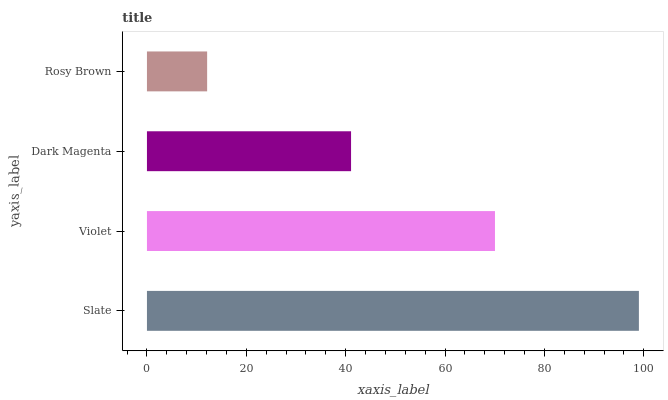Is Rosy Brown the minimum?
Answer yes or no. Yes. Is Slate the maximum?
Answer yes or no. Yes. Is Violet the minimum?
Answer yes or no. No. Is Violet the maximum?
Answer yes or no. No. Is Slate greater than Violet?
Answer yes or no. Yes. Is Violet less than Slate?
Answer yes or no. Yes. Is Violet greater than Slate?
Answer yes or no. No. Is Slate less than Violet?
Answer yes or no. No. Is Violet the high median?
Answer yes or no. Yes. Is Dark Magenta the low median?
Answer yes or no. Yes. Is Rosy Brown the high median?
Answer yes or no. No. Is Slate the low median?
Answer yes or no. No. 